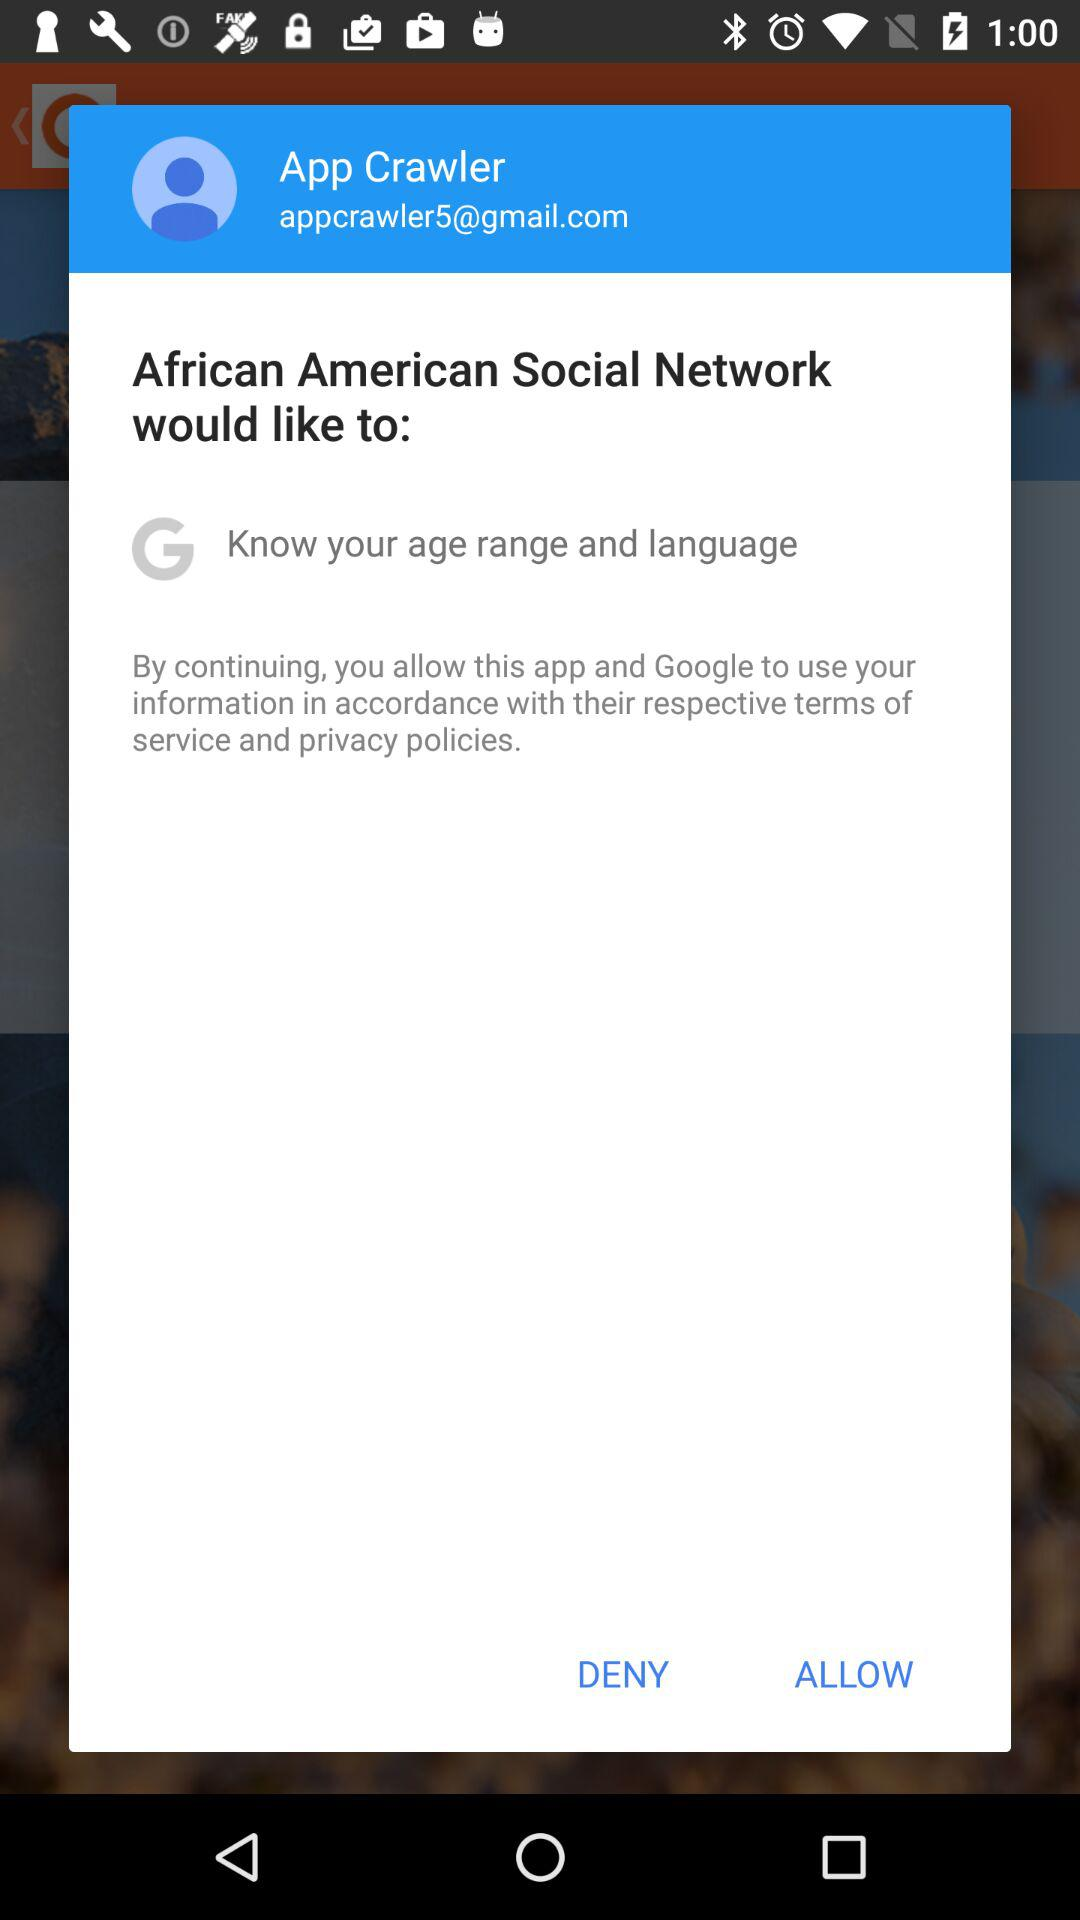What is the user name? The user name is App Crawler. 